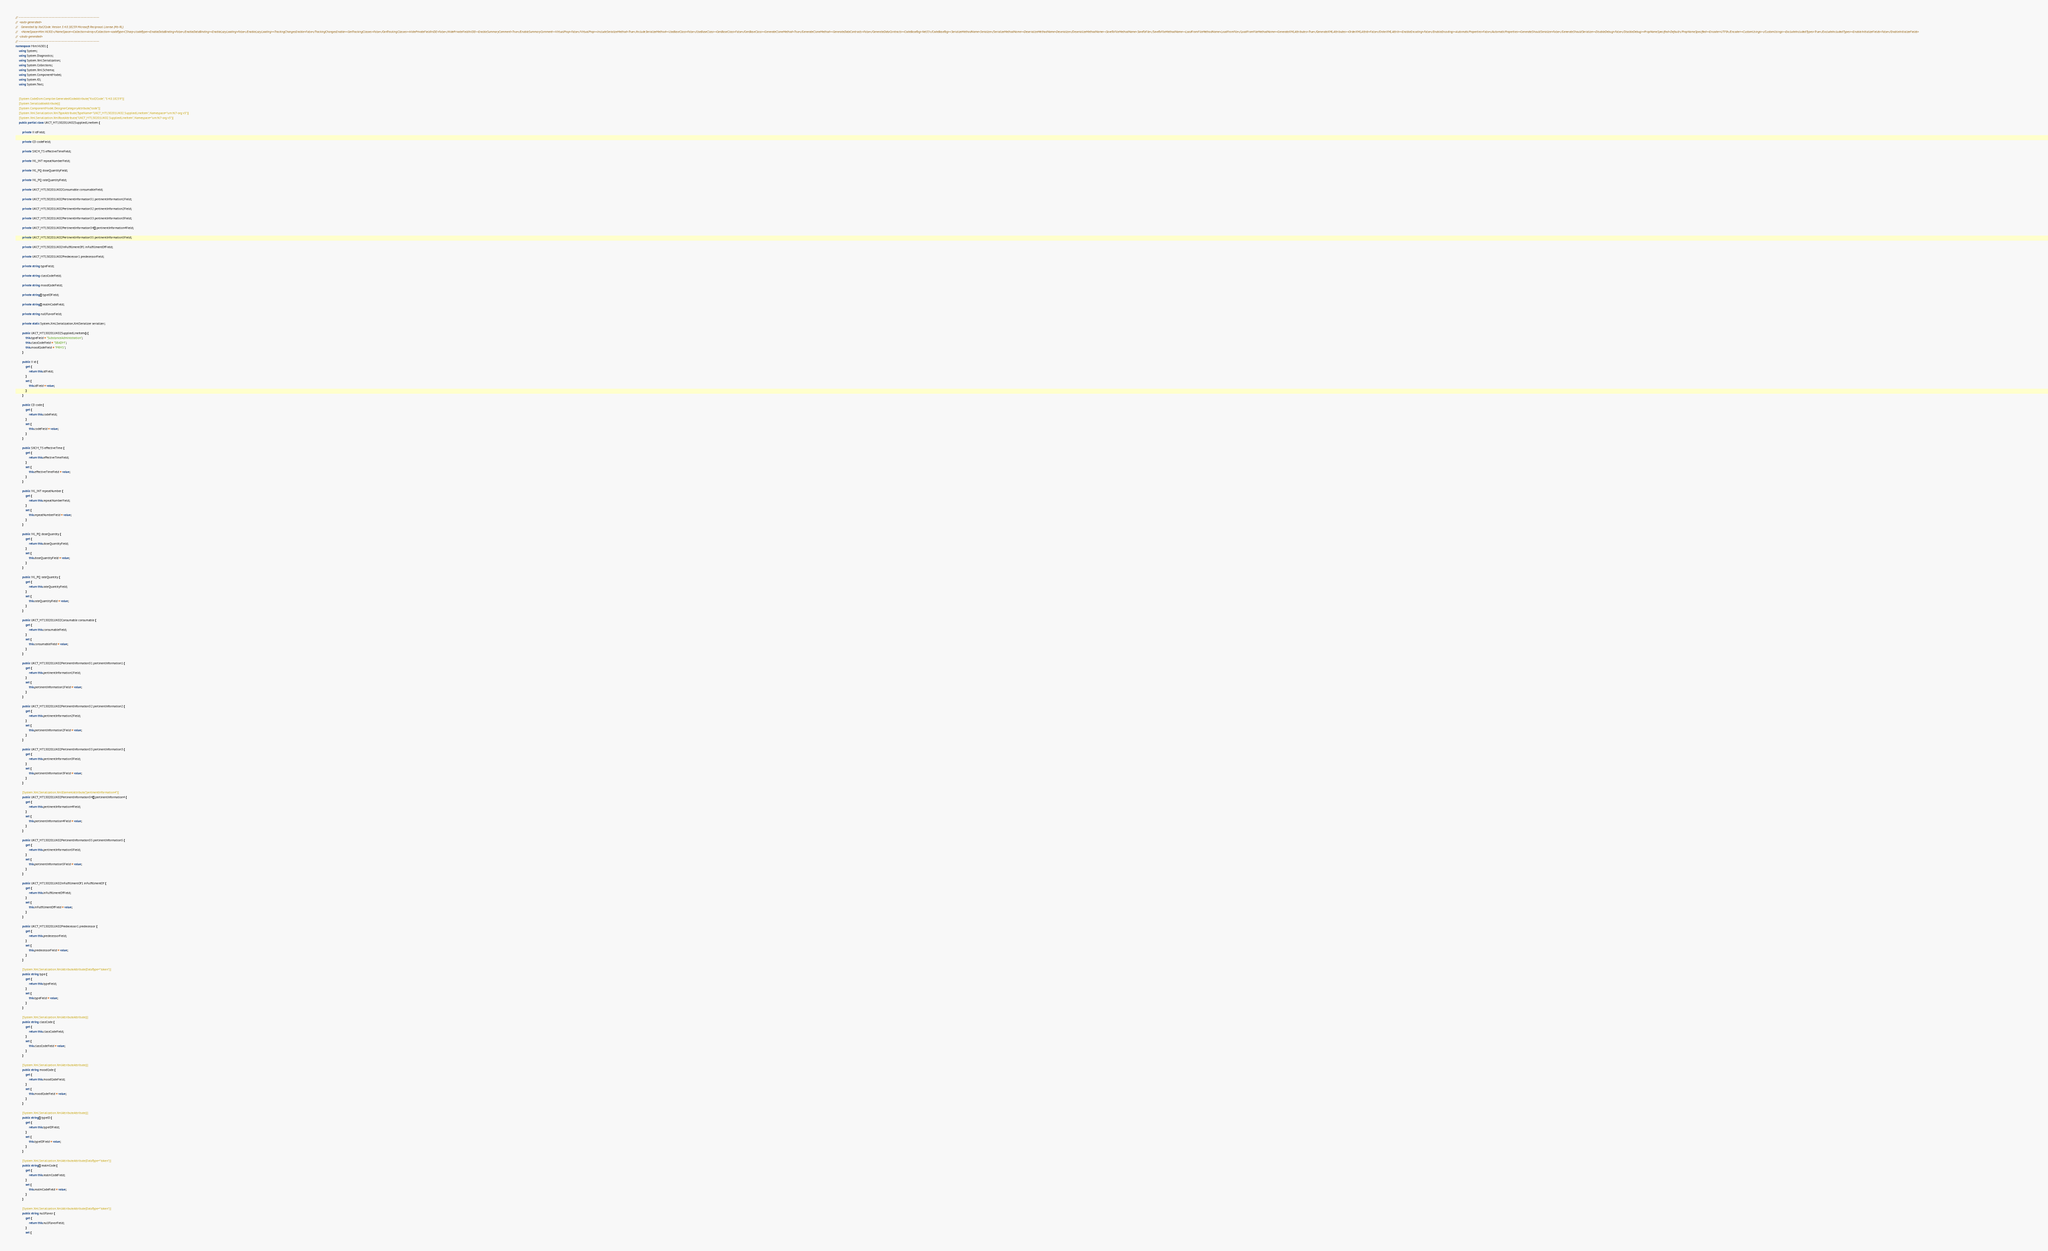<code> <loc_0><loc_0><loc_500><loc_500><_C#_>// ------------------------------------------------------------------------------
//  <auto-generated>
//    Generated by Xsd2Code. Version 3.4.0.18239 Microsoft Reciprocal License (Ms-RL) 
//    <NameSpace>Mim.V6301</NameSpace><Collection>Array</Collection><codeType>CSharp</codeType><EnableDataBinding>False</EnableDataBinding><EnableLazyLoading>False</EnableLazyLoading><TrackingChangesEnable>False</TrackingChangesEnable><GenTrackingClasses>False</GenTrackingClasses><HidePrivateFieldInIDE>False</HidePrivateFieldInIDE><EnableSummaryComment>True</EnableSummaryComment><VirtualProp>False</VirtualProp><IncludeSerializeMethod>True</IncludeSerializeMethod><UseBaseClass>False</UseBaseClass><GenBaseClass>False</GenBaseClass><GenerateCloneMethod>True</GenerateCloneMethod><GenerateDataContracts>False</GenerateDataContracts><CodeBaseTag>Net35</CodeBaseTag><SerializeMethodName>Serialize</SerializeMethodName><DeserializeMethodName>Deserialize</DeserializeMethodName><SaveToFileMethodName>SaveToFile</SaveToFileMethodName><LoadFromFileMethodName>LoadFromFile</LoadFromFileMethodName><GenerateXMLAttributes>True</GenerateXMLAttributes><OrderXMLAttrib>False</OrderXMLAttrib><EnableEncoding>False</EnableEncoding><AutomaticProperties>False</AutomaticProperties><GenerateShouldSerialize>False</GenerateShouldSerialize><DisableDebug>False</DisableDebug><PropNameSpecified>Default</PropNameSpecified><Encoder>UTF8</Encoder><CustomUsings></CustomUsings><ExcludeIncludedTypes>True</ExcludeIncludedTypes><EnableInitializeFields>False</EnableInitializeFields>
//  </auto-generated>
// ------------------------------------------------------------------------------
namespace Mim.V6301 {
    using System;
    using System.Diagnostics;
    using System.Xml.Serialization;
    using System.Collections;
    using System.Xml.Schema;
    using System.ComponentModel;
    using System.IO;
    using System.Text;
    
    
    [System.CodeDom.Compiler.GeneratedCodeAttribute("Xsd2Code", "3.4.0.18239")]
    [System.SerializableAttribute()]
    [System.ComponentModel.DesignerCategoryAttribute("code")]
    [System.Xml.Serialization.XmlTypeAttribute(TypeName="UKCT_MT130201UK02.SuppliedLineItem", Namespace="urn:hl7-org:v3")]
    [System.Xml.Serialization.XmlRootAttribute("UKCT_MT130201UK02.SuppliedLineItem", Namespace="urn:hl7-org:v3")]
    public partial class UKCT_MT130201UK02SuppliedLineItem {
        
        private II idField;
        
        private CD codeField;
        
        private SXCM_TS effectiveTimeField;
        
        private IVL_INT repeatNumberField;
        
        private IVL_PQ doseQuantityField;
        
        private IVL_PQ rateQuantityField;
        
        private UKCT_MT130201UK02Consumable consumableField;
        
        private UKCT_MT130201UK02PertinentInformation31 pertinentInformation1Field;
        
        private UKCT_MT130201UK02PertinentInformation32 pertinentInformation2Field;
        
        private UKCT_MT130201UK02PertinentInformation33 pertinentInformation3Field;
        
        private UKCT_MT130201UK02PertinentInformation34[] pertinentInformation4Field;
        
        private UKCT_MT130201UK02PertinentInformation35 pertinentInformation5Field;
        
        private UKCT_MT130201UK02InFulfillmentOf1 inFulfillmentOfField;
        
        private UKCT_MT130201UK02Predecessor1 predecessorField;
        
        private string typeField;
        
        private string classCodeField;
        
        private string moodCodeField;
        
        private string[] typeIDField;
        
        private string[] realmCodeField;
        
        private string nullFlavorField;
        
        private static System.Xml.Serialization.XmlSerializer serializer;
        
        public UKCT_MT130201UK02SuppliedLineItem() {
            this.typeField = "SubstanceAdministration";
            this.classCodeField = "SBADM";
            this.moodCodeField = "PRMS";
        }
        
        public II id {
            get {
                return this.idField;
            }
            set {
                this.idField = value;
            }
        }
        
        public CD code {
            get {
                return this.codeField;
            }
            set {
                this.codeField = value;
            }
        }
        
        public SXCM_TS effectiveTime {
            get {
                return this.effectiveTimeField;
            }
            set {
                this.effectiveTimeField = value;
            }
        }
        
        public IVL_INT repeatNumber {
            get {
                return this.repeatNumberField;
            }
            set {
                this.repeatNumberField = value;
            }
        }
        
        public IVL_PQ doseQuantity {
            get {
                return this.doseQuantityField;
            }
            set {
                this.doseQuantityField = value;
            }
        }
        
        public IVL_PQ rateQuantity {
            get {
                return this.rateQuantityField;
            }
            set {
                this.rateQuantityField = value;
            }
        }
        
        public UKCT_MT130201UK02Consumable consumable {
            get {
                return this.consumableField;
            }
            set {
                this.consumableField = value;
            }
        }
        
        public UKCT_MT130201UK02PertinentInformation31 pertinentInformation1 {
            get {
                return this.pertinentInformation1Field;
            }
            set {
                this.pertinentInformation1Field = value;
            }
        }
        
        public UKCT_MT130201UK02PertinentInformation32 pertinentInformation2 {
            get {
                return this.pertinentInformation2Field;
            }
            set {
                this.pertinentInformation2Field = value;
            }
        }
        
        public UKCT_MT130201UK02PertinentInformation33 pertinentInformation3 {
            get {
                return this.pertinentInformation3Field;
            }
            set {
                this.pertinentInformation3Field = value;
            }
        }
        
        [System.Xml.Serialization.XmlElementAttribute("pertinentInformation4")]
        public UKCT_MT130201UK02PertinentInformation34[] pertinentInformation4 {
            get {
                return this.pertinentInformation4Field;
            }
            set {
                this.pertinentInformation4Field = value;
            }
        }
        
        public UKCT_MT130201UK02PertinentInformation35 pertinentInformation5 {
            get {
                return this.pertinentInformation5Field;
            }
            set {
                this.pertinentInformation5Field = value;
            }
        }
        
        public UKCT_MT130201UK02InFulfillmentOf1 inFulfillmentOf {
            get {
                return this.inFulfillmentOfField;
            }
            set {
                this.inFulfillmentOfField = value;
            }
        }
        
        public UKCT_MT130201UK02Predecessor1 predecessor {
            get {
                return this.predecessorField;
            }
            set {
                this.predecessorField = value;
            }
        }
        
        [System.Xml.Serialization.XmlAttributeAttribute(DataType="token")]
        public string type {
            get {
                return this.typeField;
            }
            set {
                this.typeField = value;
            }
        }
        
        [System.Xml.Serialization.XmlAttributeAttribute()]
        public string classCode {
            get {
                return this.classCodeField;
            }
            set {
                this.classCodeField = value;
            }
        }
        
        [System.Xml.Serialization.XmlAttributeAttribute()]
        public string moodCode {
            get {
                return this.moodCodeField;
            }
            set {
                this.moodCodeField = value;
            }
        }
        
        [System.Xml.Serialization.XmlAttributeAttribute()]
        public string[] typeID {
            get {
                return this.typeIDField;
            }
            set {
                this.typeIDField = value;
            }
        }
        
        [System.Xml.Serialization.XmlAttributeAttribute(DataType="token")]
        public string[] realmCode {
            get {
                return this.realmCodeField;
            }
            set {
                this.realmCodeField = value;
            }
        }
        
        [System.Xml.Serialization.XmlAttributeAttribute(DataType="token")]
        public string nullFlavor {
            get {
                return this.nullFlavorField;
            }
            set {</code> 